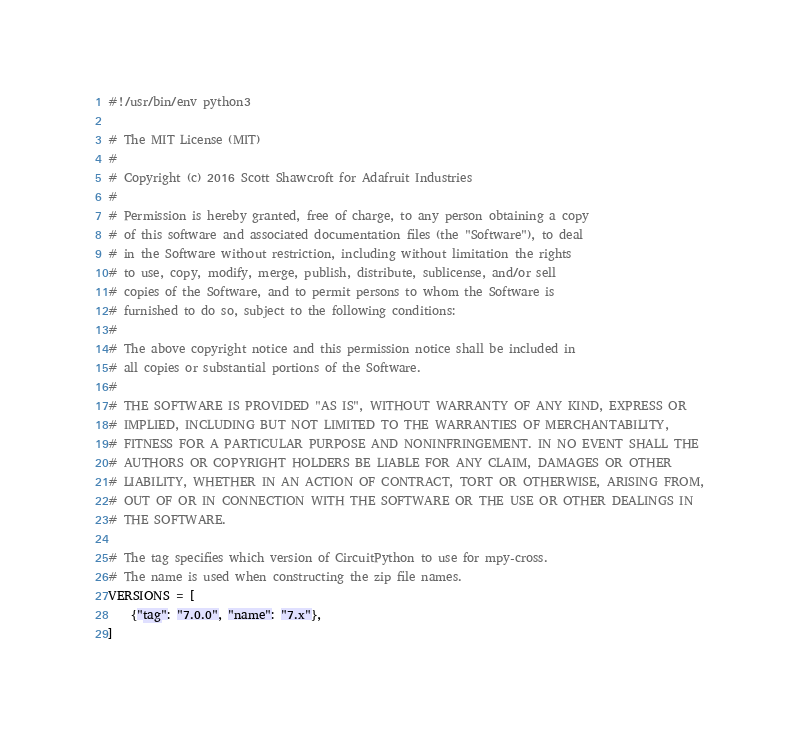Convert code to text. <code><loc_0><loc_0><loc_500><loc_500><_Python_>#!/usr/bin/env python3

# The MIT License (MIT)
#
# Copyright (c) 2016 Scott Shawcroft for Adafruit Industries
#
# Permission is hereby granted, free of charge, to any person obtaining a copy
# of this software and associated documentation files (the "Software"), to deal
# in the Software without restriction, including without limitation the rights
# to use, copy, modify, merge, publish, distribute, sublicense, and/or sell
# copies of the Software, and to permit persons to whom the Software is
# furnished to do so, subject to the following conditions:
#
# The above copyright notice and this permission notice shall be included in
# all copies or substantial portions of the Software.
#
# THE SOFTWARE IS PROVIDED "AS IS", WITHOUT WARRANTY OF ANY KIND, EXPRESS OR
# IMPLIED, INCLUDING BUT NOT LIMITED TO THE WARRANTIES OF MERCHANTABILITY,
# FITNESS FOR A PARTICULAR PURPOSE AND NONINFRINGEMENT. IN NO EVENT SHALL THE
# AUTHORS OR COPYRIGHT HOLDERS BE LIABLE FOR ANY CLAIM, DAMAGES OR OTHER
# LIABILITY, WHETHER IN AN ACTION OF CONTRACT, TORT OR OTHERWISE, ARISING FROM,
# OUT OF OR IN CONNECTION WITH THE SOFTWARE OR THE USE OR OTHER DEALINGS IN
# THE SOFTWARE.

# The tag specifies which version of CircuitPython to use for mpy-cross.
# The name is used when constructing the zip file names.
VERSIONS = [
    {"tag": "7.0.0", "name": "7.x"},
]
</code> 